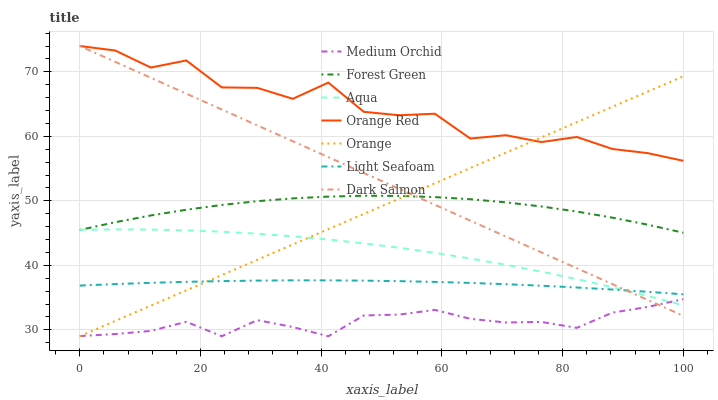Does Medium Orchid have the minimum area under the curve?
Answer yes or no. Yes. Does Orange Red have the maximum area under the curve?
Answer yes or no. Yes. Does Aqua have the minimum area under the curve?
Answer yes or no. No. Does Aqua have the maximum area under the curve?
Answer yes or no. No. Is Dark Salmon the smoothest?
Answer yes or no. Yes. Is Orange Red the roughest?
Answer yes or no. Yes. Is Aqua the smoothest?
Answer yes or no. No. Is Aqua the roughest?
Answer yes or no. No. Does Medium Orchid have the lowest value?
Answer yes or no. Yes. Does Aqua have the lowest value?
Answer yes or no. No. Does Orange Red have the highest value?
Answer yes or no. Yes. Does Aqua have the highest value?
Answer yes or no. No. Is Medium Orchid less than Orange Red?
Answer yes or no. Yes. Is Light Seafoam greater than Medium Orchid?
Answer yes or no. Yes. Does Orange intersect Dark Salmon?
Answer yes or no. Yes. Is Orange less than Dark Salmon?
Answer yes or no. No. Is Orange greater than Dark Salmon?
Answer yes or no. No. Does Medium Orchid intersect Orange Red?
Answer yes or no. No. 